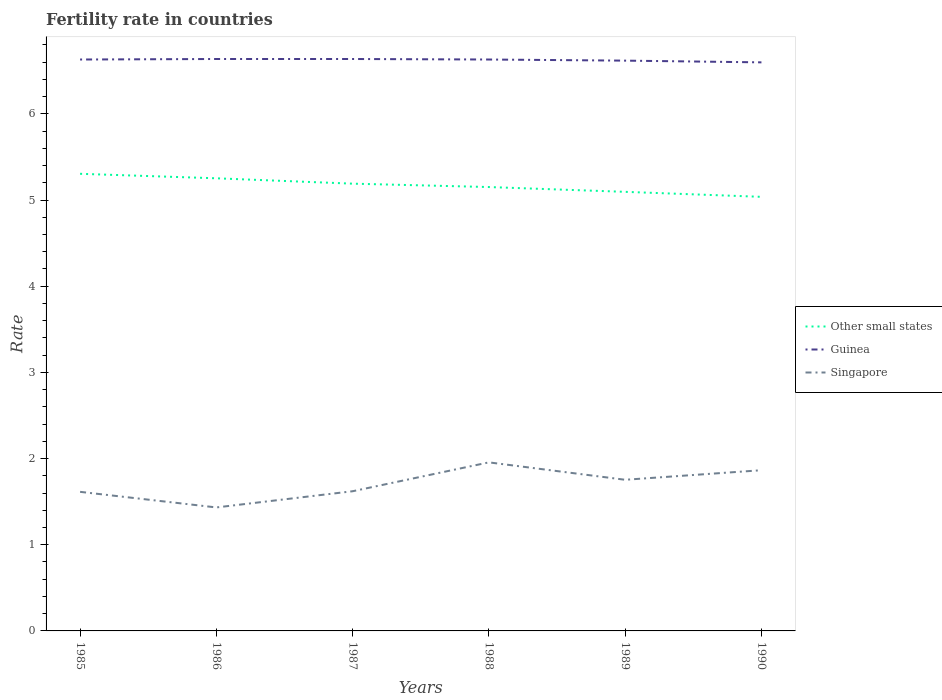Is the number of lines equal to the number of legend labels?
Make the answer very short. Yes. Across all years, what is the maximum fertility rate in Other small states?
Provide a succinct answer. 5.04. In which year was the fertility rate in Guinea maximum?
Keep it short and to the point. 1990. What is the total fertility rate in Singapore in the graph?
Your answer should be very brief. -0.34. What is the difference between the highest and the second highest fertility rate in Singapore?
Provide a short and direct response. 0.52. How many lines are there?
Provide a short and direct response. 3. Are the values on the major ticks of Y-axis written in scientific E-notation?
Ensure brevity in your answer.  No. Where does the legend appear in the graph?
Your answer should be very brief. Center right. How are the legend labels stacked?
Your response must be concise. Vertical. What is the title of the graph?
Give a very brief answer. Fertility rate in countries. What is the label or title of the X-axis?
Keep it short and to the point. Years. What is the label or title of the Y-axis?
Ensure brevity in your answer.  Rate. What is the Rate of Other small states in 1985?
Your answer should be compact. 5.3. What is the Rate in Guinea in 1985?
Make the answer very short. 6.63. What is the Rate of Singapore in 1985?
Offer a terse response. 1.61. What is the Rate in Other small states in 1986?
Offer a terse response. 5.25. What is the Rate in Guinea in 1986?
Your answer should be compact. 6.64. What is the Rate of Singapore in 1986?
Offer a very short reply. 1.43. What is the Rate in Other small states in 1987?
Your answer should be compact. 5.19. What is the Rate of Guinea in 1987?
Your response must be concise. 6.64. What is the Rate in Singapore in 1987?
Give a very brief answer. 1.62. What is the Rate of Other small states in 1988?
Your answer should be compact. 5.15. What is the Rate in Guinea in 1988?
Make the answer very short. 6.63. What is the Rate in Singapore in 1988?
Your response must be concise. 1.96. What is the Rate of Other small states in 1989?
Provide a short and direct response. 5.1. What is the Rate of Guinea in 1989?
Offer a very short reply. 6.62. What is the Rate in Singapore in 1989?
Make the answer very short. 1.75. What is the Rate of Other small states in 1990?
Provide a short and direct response. 5.04. What is the Rate of Guinea in 1990?
Offer a terse response. 6.6. What is the Rate in Singapore in 1990?
Provide a short and direct response. 1.86. Across all years, what is the maximum Rate of Other small states?
Make the answer very short. 5.3. Across all years, what is the maximum Rate in Guinea?
Give a very brief answer. 6.64. Across all years, what is the maximum Rate in Singapore?
Your response must be concise. 1.96. Across all years, what is the minimum Rate in Other small states?
Provide a short and direct response. 5.04. Across all years, what is the minimum Rate in Guinea?
Ensure brevity in your answer.  6.6. Across all years, what is the minimum Rate of Singapore?
Make the answer very short. 1.43. What is the total Rate of Other small states in the graph?
Your answer should be compact. 31.03. What is the total Rate in Guinea in the graph?
Offer a very short reply. 39.75. What is the total Rate in Singapore in the graph?
Your answer should be compact. 10.24. What is the difference between the Rate of Other small states in 1985 and that in 1986?
Your response must be concise. 0.05. What is the difference between the Rate of Guinea in 1985 and that in 1986?
Your answer should be very brief. -0.01. What is the difference between the Rate in Singapore in 1985 and that in 1986?
Your answer should be very brief. 0.18. What is the difference between the Rate in Other small states in 1985 and that in 1987?
Offer a very short reply. 0.11. What is the difference between the Rate in Guinea in 1985 and that in 1987?
Give a very brief answer. -0.01. What is the difference between the Rate of Singapore in 1985 and that in 1987?
Provide a short and direct response. -0.01. What is the difference between the Rate in Other small states in 1985 and that in 1988?
Provide a short and direct response. 0.15. What is the difference between the Rate in Singapore in 1985 and that in 1988?
Give a very brief answer. -0.34. What is the difference between the Rate of Other small states in 1985 and that in 1989?
Your answer should be very brief. 0.21. What is the difference between the Rate of Guinea in 1985 and that in 1989?
Keep it short and to the point. 0.01. What is the difference between the Rate in Singapore in 1985 and that in 1989?
Your response must be concise. -0.14. What is the difference between the Rate in Other small states in 1985 and that in 1990?
Offer a terse response. 0.27. What is the difference between the Rate in Guinea in 1985 and that in 1990?
Offer a terse response. 0.03. What is the difference between the Rate of Singapore in 1985 and that in 1990?
Ensure brevity in your answer.  -0.25. What is the difference between the Rate of Other small states in 1986 and that in 1987?
Your response must be concise. 0.06. What is the difference between the Rate of Singapore in 1986 and that in 1987?
Your answer should be very brief. -0.19. What is the difference between the Rate in Other small states in 1986 and that in 1988?
Your answer should be compact. 0.1. What is the difference between the Rate of Guinea in 1986 and that in 1988?
Your response must be concise. 0.01. What is the difference between the Rate in Singapore in 1986 and that in 1988?
Keep it short and to the point. -0.52. What is the difference between the Rate of Other small states in 1986 and that in 1989?
Provide a short and direct response. 0.16. What is the difference between the Rate in Guinea in 1986 and that in 1989?
Your answer should be very brief. 0.02. What is the difference between the Rate in Singapore in 1986 and that in 1989?
Offer a terse response. -0.32. What is the difference between the Rate of Other small states in 1986 and that in 1990?
Provide a succinct answer. 0.22. What is the difference between the Rate of Guinea in 1986 and that in 1990?
Make the answer very short. 0.04. What is the difference between the Rate in Singapore in 1986 and that in 1990?
Provide a short and direct response. -0.43. What is the difference between the Rate of Other small states in 1987 and that in 1988?
Make the answer very short. 0.04. What is the difference between the Rate in Guinea in 1987 and that in 1988?
Your answer should be compact. 0.01. What is the difference between the Rate of Singapore in 1987 and that in 1988?
Your response must be concise. -0.34. What is the difference between the Rate in Other small states in 1987 and that in 1989?
Offer a terse response. 0.09. What is the difference between the Rate in Guinea in 1987 and that in 1989?
Make the answer very short. 0.02. What is the difference between the Rate of Singapore in 1987 and that in 1989?
Provide a short and direct response. -0.13. What is the difference between the Rate in Other small states in 1987 and that in 1990?
Offer a very short reply. 0.15. What is the difference between the Rate in Guinea in 1987 and that in 1990?
Give a very brief answer. 0.04. What is the difference between the Rate of Singapore in 1987 and that in 1990?
Offer a terse response. -0.24. What is the difference between the Rate in Other small states in 1988 and that in 1989?
Your answer should be very brief. 0.06. What is the difference between the Rate of Guinea in 1988 and that in 1989?
Keep it short and to the point. 0.01. What is the difference between the Rate of Singapore in 1988 and that in 1989?
Make the answer very short. 0.2. What is the difference between the Rate in Other small states in 1988 and that in 1990?
Provide a succinct answer. 0.11. What is the difference between the Rate of Guinea in 1988 and that in 1990?
Give a very brief answer. 0.03. What is the difference between the Rate of Singapore in 1988 and that in 1990?
Give a very brief answer. 0.09. What is the difference between the Rate of Other small states in 1989 and that in 1990?
Give a very brief answer. 0.06. What is the difference between the Rate of Singapore in 1989 and that in 1990?
Make the answer very short. -0.11. What is the difference between the Rate in Other small states in 1985 and the Rate in Guinea in 1986?
Make the answer very short. -1.33. What is the difference between the Rate in Other small states in 1985 and the Rate in Singapore in 1986?
Your response must be concise. 3.87. What is the difference between the Rate of Guinea in 1985 and the Rate of Singapore in 1986?
Your answer should be compact. 5.2. What is the difference between the Rate in Other small states in 1985 and the Rate in Guinea in 1987?
Provide a short and direct response. -1.33. What is the difference between the Rate in Other small states in 1985 and the Rate in Singapore in 1987?
Give a very brief answer. 3.68. What is the difference between the Rate in Guinea in 1985 and the Rate in Singapore in 1987?
Give a very brief answer. 5.01. What is the difference between the Rate in Other small states in 1985 and the Rate in Guinea in 1988?
Ensure brevity in your answer.  -1.33. What is the difference between the Rate of Other small states in 1985 and the Rate of Singapore in 1988?
Ensure brevity in your answer.  3.35. What is the difference between the Rate of Guinea in 1985 and the Rate of Singapore in 1988?
Your answer should be very brief. 4.67. What is the difference between the Rate of Other small states in 1985 and the Rate of Guinea in 1989?
Give a very brief answer. -1.31. What is the difference between the Rate of Other small states in 1985 and the Rate of Singapore in 1989?
Your answer should be compact. 3.55. What is the difference between the Rate of Guinea in 1985 and the Rate of Singapore in 1989?
Give a very brief answer. 4.88. What is the difference between the Rate in Other small states in 1985 and the Rate in Guinea in 1990?
Keep it short and to the point. -1.29. What is the difference between the Rate in Other small states in 1985 and the Rate in Singapore in 1990?
Your answer should be compact. 3.44. What is the difference between the Rate in Guinea in 1985 and the Rate in Singapore in 1990?
Your answer should be compact. 4.77. What is the difference between the Rate of Other small states in 1986 and the Rate of Guinea in 1987?
Provide a short and direct response. -1.38. What is the difference between the Rate in Other small states in 1986 and the Rate in Singapore in 1987?
Your answer should be compact. 3.63. What is the difference between the Rate in Guinea in 1986 and the Rate in Singapore in 1987?
Your answer should be very brief. 5.02. What is the difference between the Rate in Other small states in 1986 and the Rate in Guinea in 1988?
Keep it short and to the point. -1.38. What is the difference between the Rate in Other small states in 1986 and the Rate in Singapore in 1988?
Give a very brief answer. 3.3. What is the difference between the Rate of Guinea in 1986 and the Rate of Singapore in 1988?
Provide a short and direct response. 4.68. What is the difference between the Rate in Other small states in 1986 and the Rate in Guinea in 1989?
Provide a succinct answer. -1.37. What is the difference between the Rate in Other small states in 1986 and the Rate in Singapore in 1989?
Provide a short and direct response. 3.5. What is the difference between the Rate in Guinea in 1986 and the Rate in Singapore in 1989?
Make the answer very short. 4.88. What is the difference between the Rate of Other small states in 1986 and the Rate of Guinea in 1990?
Make the answer very short. -1.35. What is the difference between the Rate in Other small states in 1986 and the Rate in Singapore in 1990?
Your response must be concise. 3.39. What is the difference between the Rate of Guinea in 1986 and the Rate of Singapore in 1990?
Your response must be concise. 4.77. What is the difference between the Rate in Other small states in 1987 and the Rate in Guinea in 1988?
Offer a terse response. -1.44. What is the difference between the Rate in Other small states in 1987 and the Rate in Singapore in 1988?
Offer a terse response. 3.23. What is the difference between the Rate in Guinea in 1987 and the Rate in Singapore in 1988?
Your response must be concise. 4.68. What is the difference between the Rate of Other small states in 1987 and the Rate of Guinea in 1989?
Give a very brief answer. -1.43. What is the difference between the Rate in Other small states in 1987 and the Rate in Singapore in 1989?
Provide a short and direct response. 3.44. What is the difference between the Rate of Guinea in 1987 and the Rate of Singapore in 1989?
Keep it short and to the point. 4.88. What is the difference between the Rate of Other small states in 1987 and the Rate of Guinea in 1990?
Provide a short and direct response. -1.41. What is the difference between the Rate in Other small states in 1987 and the Rate in Singapore in 1990?
Make the answer very short. 3.33. What is the difference between the Rate in Guinea in 1987 and the Rate in Singapore in 1990?
Your response must be concise. 4.77. What is the difference between the Rate of Other small states in 1988 and the Rate of Guinea in 1989?
Keep it short and to the point. -1.47. What is the difference between the Rate of Other small states in 1988 and the Rate of Singapore in 1989?
Keep it short and to the point. 3.4. What is the difference between the Rate of Guinea in 1988 and the Rate of Singapore in 1989?
Keep it short and to the point. 4.88. What is the difference between the Rate in Other small states in 1988 and the Rate in Guinea in 1990?
Your answer should be compact. -1.45. What is the difference between the Rate of Other small states in 1988 and the Rate of Singapore in 1990?
Offer a terse response. 3.29. What is the difference between the Rate in Guinea in 1988 and the Rate in Singapore in 1990?
Keep it short and to the point. 4.77. What is the difference between the Rate in Other small states in 1989 and the Rate in Guinea in 1990?
Ensure brevity in your answer.  -1.5. What is the difference between the Rate of Other small states in 1989 and the Rate of Singapore in 1990?
Offer a very short reply. 3.23. What is the difference between the Rate of Guinea in 1989 and the Rate of Singapore in 1990?
Give a very brief answer. 4.75. What is the average Rate of Other small states per year?
Your response must be concise. 5.17. What is the average Rate in Guinea per year?
Keep it short and to the point. 6.63. What is the average Rate in Singapore per year?
Offer a very short reply. 1.71. In the year 1985, what is the difference between the Rate of Other small states and Rate of Guinea?
Make the answer very short. -1.33. In the year 1985, what is the difference between the Rate in Other small states and Rate in Singapore?
Provide a succinct answer. 3.69. In the year 1985, what is the difference between the Rate of Guinea and Rate of Singapore?
Your answer should be compact. 5.02. In the year 1986, what is the difference between the Rate of Other small states and Rate of Guinea?
Ensure brevity in your answer.  -1.38. In the year 1986, what is the difference between the Rate of Other small states and Rate of Singapore?
Ensure brevity in your answer.  3.82. In the year 1986, what is the difference between the Rate in Guinea and Rate in Singapore?
Keep it short and to the point. 5.2. In the year 1987, what is the difference between the Rate of Other small states and Rate of Guinea?
Offer a very short reply. -1.45. In the year 1987, what is the difference between the Rate in Other small states and Rate in Singapore?
Make the answer very short. 3.57. In the year 1987, what is the difference between the Rate of Guinea and Rate of Singapore?
Offer a very short reply. 5.02. In the year 1988, what is the difference between the Rate of Other small states and Rate of Guinea?
Your answer should be compact. -1.48. In the year 1988, what is the difference between the Rate of Other small states and Rate of Singapore?
Ensure brevity in your answer.  3.19. In the year 1988, what is the difference between the Rate in Guinea and Rate in Singapore?
Your response must be concise. 4.67. In the year 1989, what is the difference between the Rate in Other small states and Rate in Guinea?
Ensure brevity in your answer.  -1.52. In the year 1989, what is the difference between the Rate in Other small states and Rate in Singapore?
Offer a very short reply. 3.34. In the year 1989, what is the difference between the Rate of Guinea and Rate of Singapore?
Your answer should be compact. 4.86. In the year 1990, what is the difference between the Rate in Other small states and Rate in Guinea?
Provide a short and direct response. -1.56. In the year 1990, what is the difference between the Rate of Other small states and Rate of Singapore?
Offer a very short reply. 3.17. In the year 1990, what is the difference between the Rate of Guinea and Rate of Singapore?
Keep it short and to the point. 4.73. What is the ratio of the Rate in Other small states in 1985 to that in 1986?
Make the answer very short. 1.01. What is the ratio of the Rate of Singapore in 1985 to that in 1986?
Your answer should be compact. 1.13. What is the ratio of the Rate in Other small states in 1985 to that in 1987?
Give a very brief answer. 1.02. What is the ratio of the Rate in Guinea in 1985 to that in 1987?
Provide a succinct answer. 1. What is the ratio of the Rate in Singapore in 1985 to that in 1987?
Provide a succinct answer. 1. What is the ratio of the Rate in Other small states in 1985 to that in 1988?
Keep it short and to the point. 1.03. What is the ratio of the Rate in Singapore in 1985 to that in 1988?
Keep it short and to the point. 0.83. What is the ratio of the Rate in Other small states in 1985 to that in 1989?
Provide a succinct answer. 1.04. What is the ratio of the Rate of Guinea in 1985 to that in 1989?
Give a very brief answer. 1. What is the ratio of the Rate in Singapore in 1985 to that in 1989?
Provide a short and direct response. 0.92. What is the ratio of the Rate in Other small states in 1985 to that in 1990?
Your answer should be compact. 1.05. What is the ratio of the Rate in Singapore in 1985 to that in 1990?
Provide a short and direct response. 0.87. What is the ratio of the Rate of Other small states in 1986 to that in 1987?
Your answer should be compact. 1.01. What is the ratio of the Rate in Singapore in 1986 to that in 1987?
Keep it short and to the point. 0.88. What is the ratio of the Rate in Other small states in 1986 to that in 1988?
Provide a succinct answer. 1.02. What is the ratio of the Rate in Guinea in 1986 to that in 1988?
Your answer should be very brief. 1. What is the ratio of the Rate of Singapore in 1986 to that in 1988?
Make the answer very short. 0.73. What is the ratio of the Rate in Other small states in 1986 to that in 1989?
Your answer should be compact. 1.03. What is the ratio of the Rate in Singapore in 1986 to that in 1989?
Provide a succinct answer. 0.82. What is the ratio of the Rate of Other small states in 1986 to that in 1990?
Your answer should be compact. 1.04. What is the ratio of the Rate in Guinea in 1986 to that in 1990?
Offer a very short reply. 1.01. What is the ratio of the Rate in Singapore in 1986 to that in 1990?
Keep it short and to the point. 0.77. What is the ratio of the Rate in Other small states in 1987 to that in 1988?
Your answer should be very brief. 1.01. What is the ratio of the Rate of Guinea in 1987 to that in 1988?
Make the answer very short. 1. What is the ratio of the Rate of Singapore in 1987 to that in 1988?
Your response must be concise. 0.83. What is the ratio of the Rate of Other small states in 1987 to that in 1989?
Provide a short and direct response. 1.02. What is the ratio of the Rate in Guinea in 1987 to that in 1989?
Your answer should be compact. 1. What is the ratio of the Rate of Singapore in 1987 to that in 1989?
Give a very brief answer. 0.92. What is the ratio of the Rate of Other small states in 1987 to that in 1990?
Your answer should be compact. 1.03. What is the ratio of the Rate of Guinea in 1987 to that in 1990?
Your response must be concise. 1.01. What is the ratio of the Rate in Singapore in 1987 to that in 1990?
Offer a very short reply. 0.87. What is the ratio of the Rate in Other small states in 1988 to that in 1989?
Ensure brevity in your answer.  1.01. What is the ratio of the Rate of Guinea in 1988 to that in 1989?
Your answer should be very brief. 1. What is the ratio of the Rate in Singapore in 1988 to that in 1989?
Your response must be concise. 1.12. What is the ratio of the Rate in Other small states in 1988 to that in 1990?
Keep it short and to the point. 1.02. What is the ratio of the Rate in Guinea in 1988 to that in 1990?
Provide a succinct answer. 1. What is the ratio of the Rate of Singapore in 1988 to that in 1990?
Give a very brief answer. 1.05. What is the ratio of the Rate in Other small states in 1989 to that in 1990?
Make the answer very short. 1.01. What is the ratio of the Rate in Singapore in 1989 to that in 1990?
Provide a succinct answer. 0.94. What is the difference between the highest and the second highest Rate in Other small states?
Your answer should be compact. 0.05. What is the difference between the highest and the second highest Rate of Guinea?
Give a very brief answer. 0. What is the difference between the highest and the second highest Rate in Singapore?
Your answer should be compact. 0.09. What is the difference between the highest and the lowest Rate in Other small states?
Your answer should be very brief. 0.27. What is the difference between the highest and the lowest Rate in Guinea?
Offer a very short reply. 0.04. What is the difference between the highest and the lowest Rate in Singapore?
Offer a terse response. 0.52. 